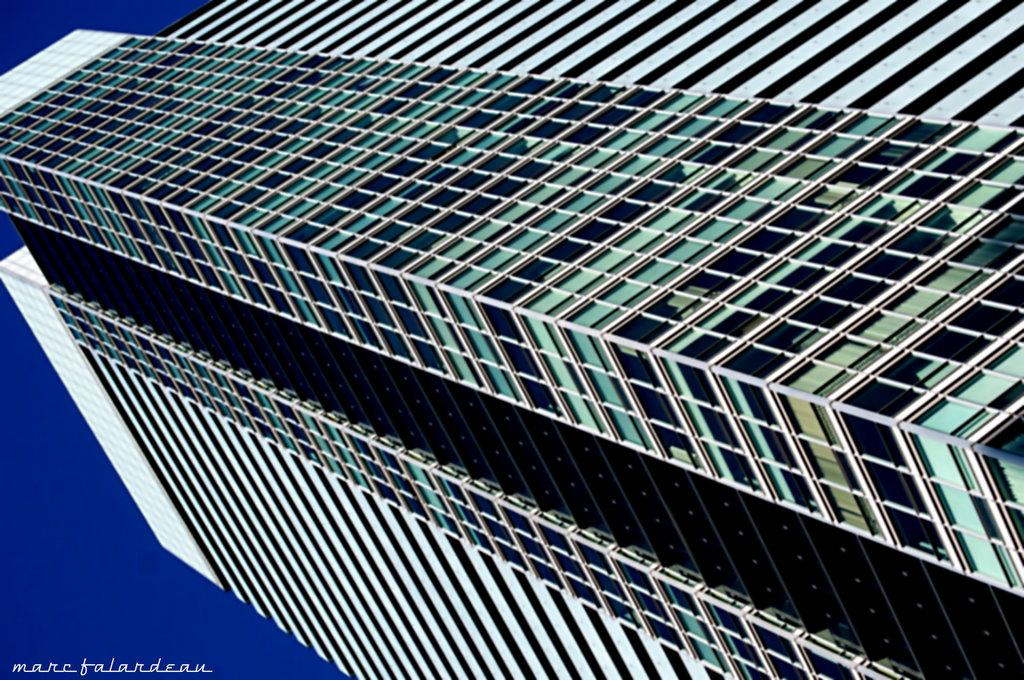What type of structures can be seen in the image? There are buildings in the image. What color is the sky in the image? The sky is blue in the image. Is there any additional mark or feature on the image? Yes, there is a watermark visible in the image. Can you describe the pain experienced by the pear in the image? There is no pear or any indication of pain in the image. 